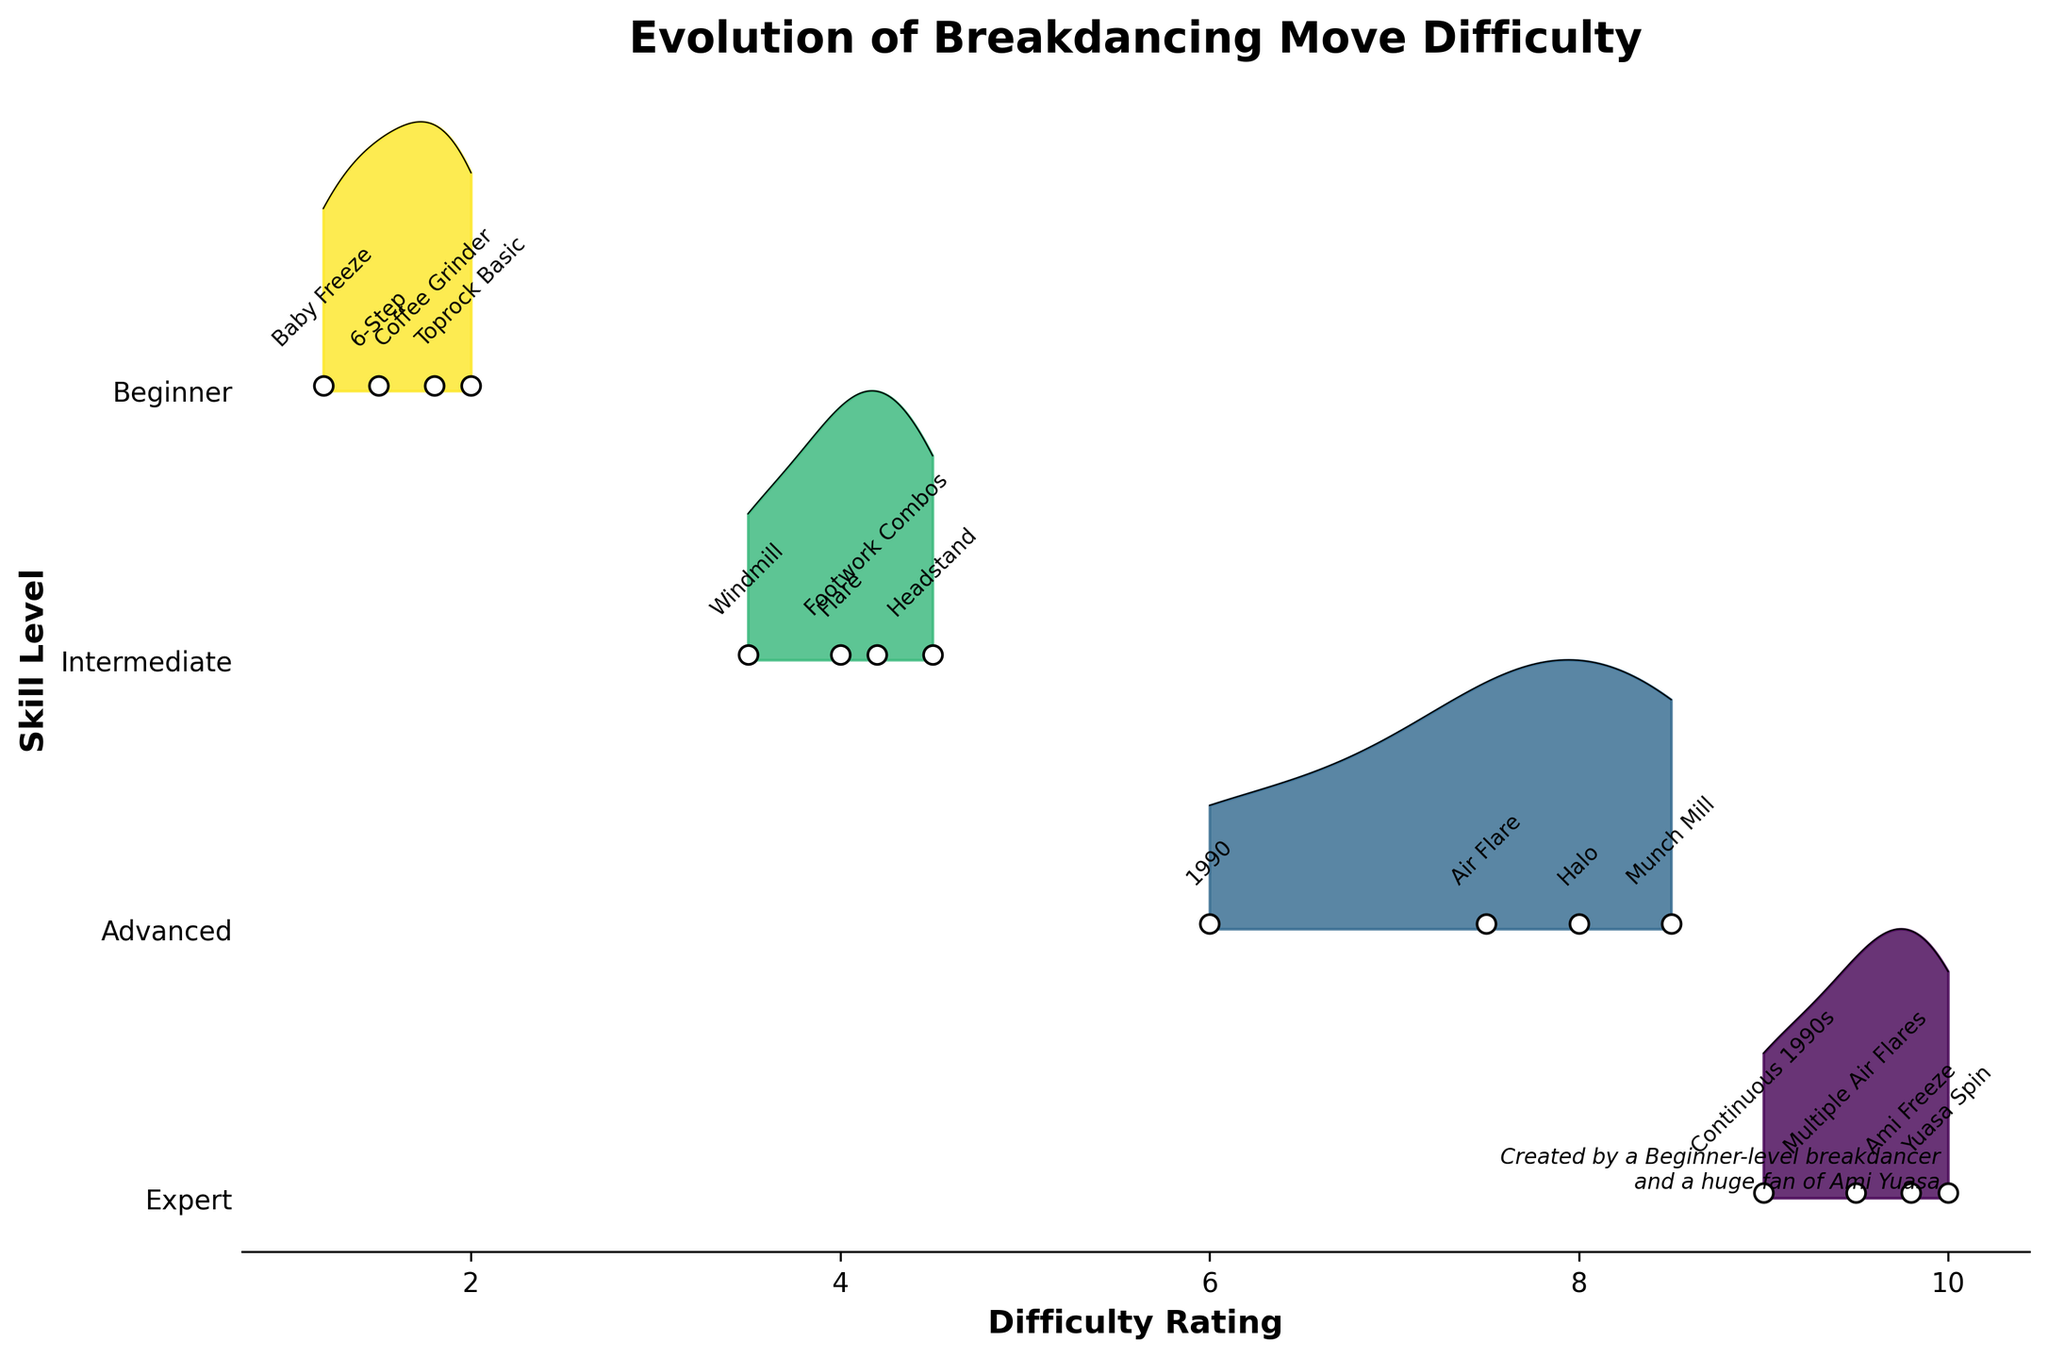what is the title of the figure? The title is typically located at the top of the figure and provides a summary of what the figure is about. In this case, it says "Evolution of Breakdancing Move Difficulty." This indicates the figure shows the changes in difficulty ratings for breakdancing moves across different skill levels.
Answer: Evolution of Breakdancing Move Difficulty Which level has the highest number of breakdancing moves listed? By counting the number of breakdancing moves listed for each level on the plot, we see that the Expert level has the most moves listed (4 moves). Other levels have fewer moves: Beginner (4), Intermediate (4), and Advanced (4).
Answer: Expert How many breakdancing moves are there at the Beginner level? By counting the moves listed under the Beginner level on the plot, we can see that there are four moves: Baby Freeze, 6-Step, Coffee Grinder, and Toprock Basic.
Answer: 4 Which move has the highest difficulty rating at the Expert level? At the Expert level, looking at the plot, the move with the highest difficulty rating appears to be "Yuasa Spin" with a rating of 10.0. This is visible as the rightmost data point in the Expert level ridgeline.
Answer: Yuasa Spin Compare the difficulty ratings of the Beginner level and Expert level. Which has higher ratings overall? By comparing the difficulty ratings for moves in the Beginner level and Expert level, it’s evident that the Expert level has higher ratings overall. For instance, beginners have ratings ranging from 1.2 to 2.0, while expert ratings range from 9.0 to 10.0.
Answer: Expert level What is the difficulty rating of the Flare move? Referring to the Intermediate level section of the plot, the Flare move is shown with a difficulty rating of 4.0.
Answer: 4.0 Which level has the widest range of difficulty ratings? By examining the spread of the difficulty ratings for each level, the Expert level shows the widest range (9.0 to 10.0). The other levels show narrower ranges.
Answer: Expert Identify the move with the lowest difficulty rating. Observing the plot, the move with the lowest difficulty rating is Baby Freeze, which has a rating of 1.2, and it is located at the Beginner level.
Answer: Baby Freeze Is there any overlap in difficulty ratings between the Intermediate and Advanced levels? There is no overlap in difficulty ratings between the Intermediate (3.5 to 4.5) and Advanced (6.0 to 8.5) levels. The smallest difficulty rating in Advanced is higher than the largest in Intermediate.
Answer: No Calculate the average difficulty rating for moves in the Beginner level. To find the average difficulty rating for Beginner level moves, sum the ratings (1.2, 1.5, 1.8, 2.0) and divide by the number of moves. The calculation is (1.2 + 1.5 + 1.8 + 2.0) / 4 = 6.5 / 4 = 1.625.
Answer: 1.625 